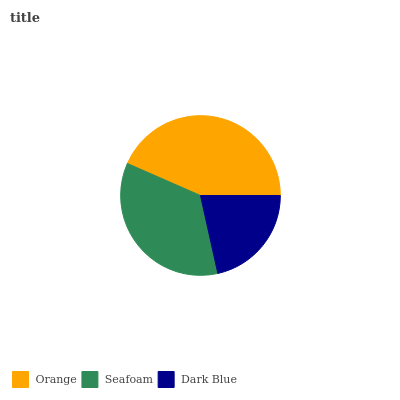Is Dark Blue the minimum?
Answer yes or no. Yes. Is Orange the maximum?
Answer yes or no. Yes. Is Seafoam the minimum?
Answer yes or no. No. Is Seafoam the maximum?
Answer yes or no. No. Is Orange greater than Seafoam?
Answer yes or no. Yes. Is Seafoam less than Orange?
Answer yes or no. Yes. Is Seafoam greater than Orange?
Answer yes or no. No. Is Orange less than Seafoam?
Answer yes or no. No. Is Seafoam the high median?
Answer yes or no. Yes. Is Seafoam the low median?
Answer yes or no. Yes. Is Orange the high median?
Answer yes or no. No. Is Dark Blue the low median?
Answer yes or no. No. 